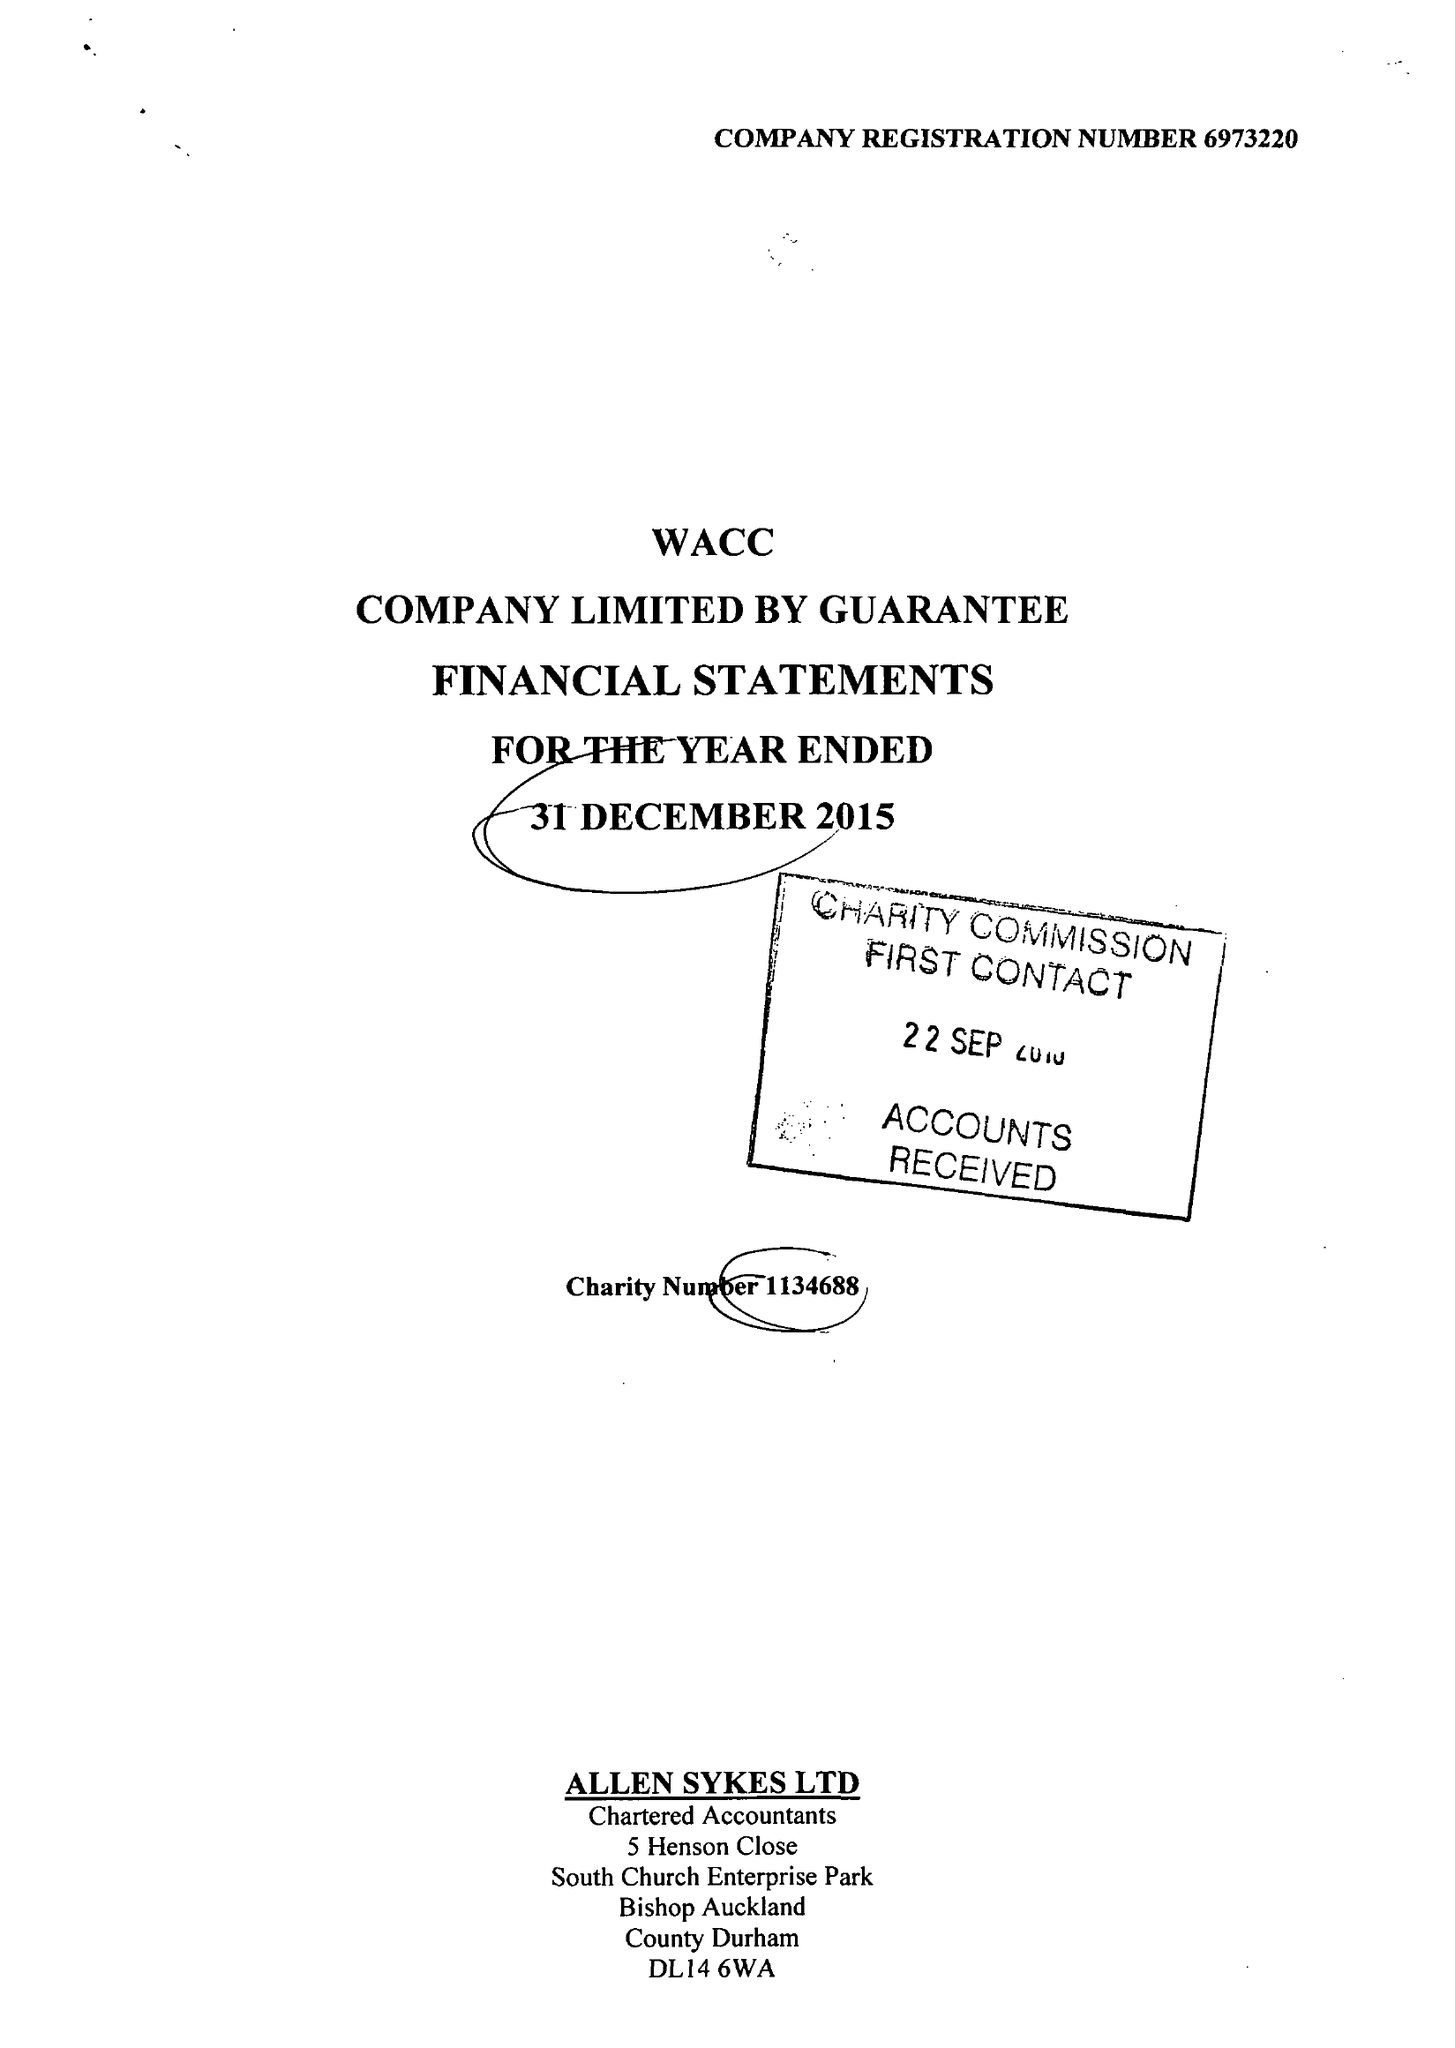What is the value for the charity_number?
Answer the question using a single word or phrase. 1134688 